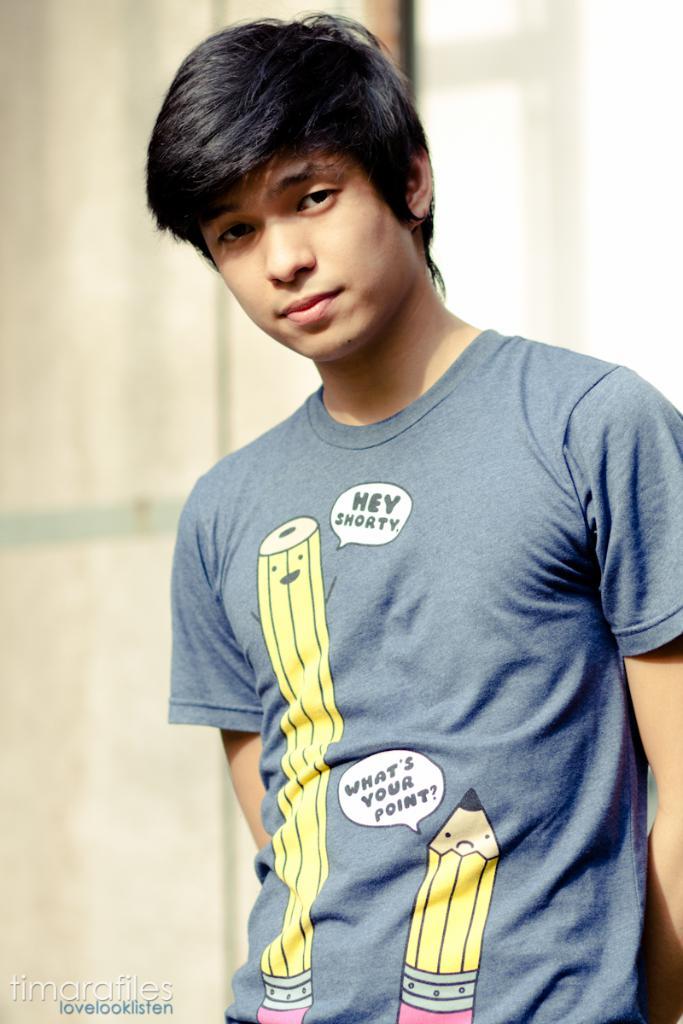What does the pencil say on his shirt?
Provide a short and direct response. Hey shorty. What question does the smaller pencil ask?
Your response must be concise. What's your point?. 